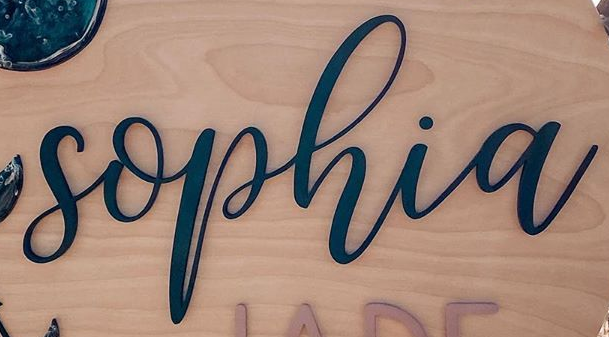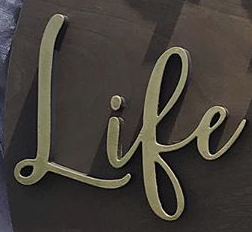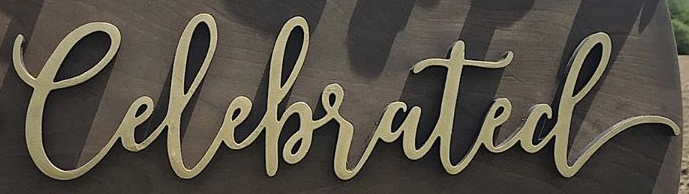What words are shown in these images in order, separated by a semicolon? sophia; Life; Celebrated 